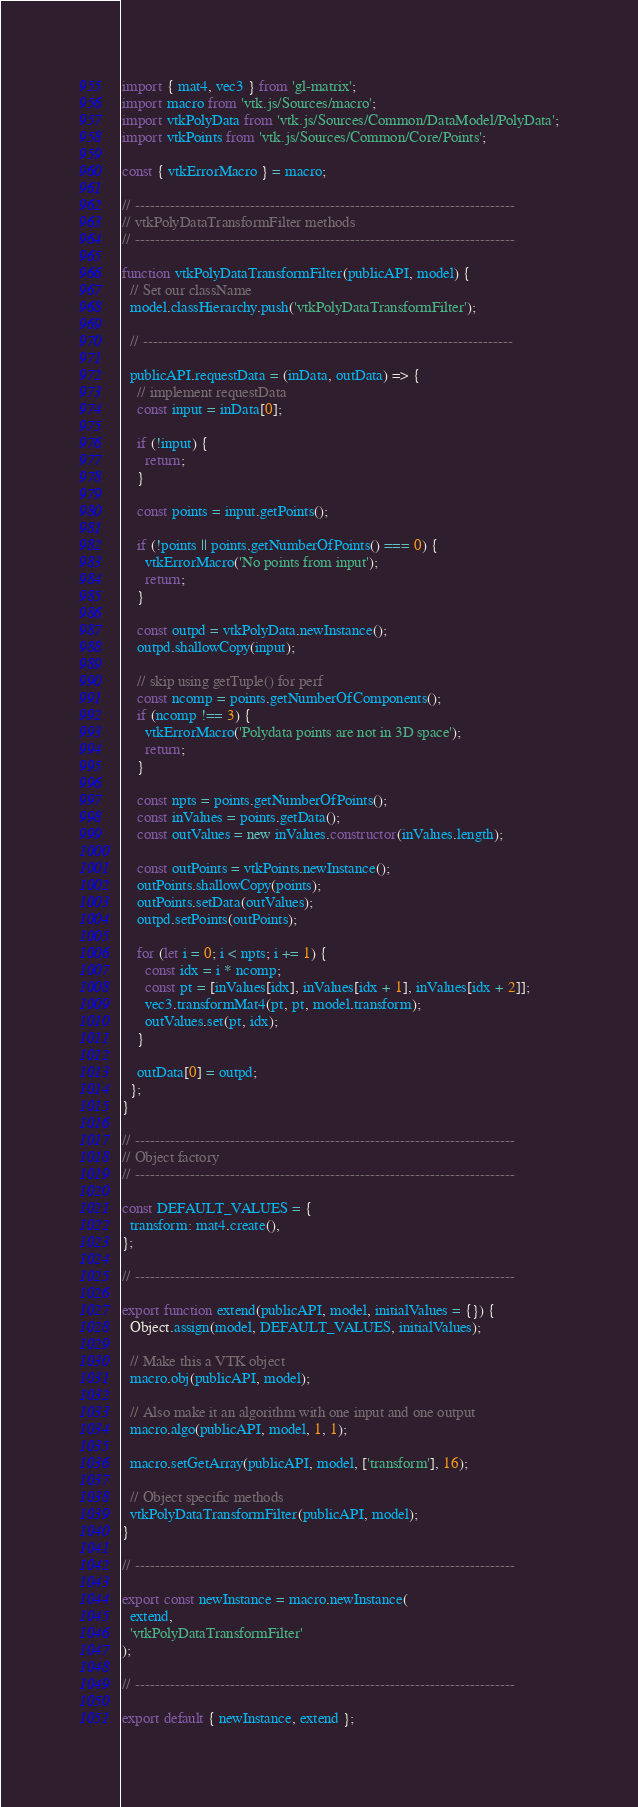<code> <loc_0><loc_0><loc_500><loc_500><_JavaScript_>import { mat4, vec3 } from 'gl-matrix';
import macro from 'vtk.js/Sources/macro';
import vtkPolyData from 'vtk.js/Sources/Common/DataModel/PolyData';
import vtkPoints from 'vtk.js/Sources/Common/Core/Points';

const { vtkErrorMacro } = macro;

// ----------------------------------------------------------------------------
// vtkPolyDataTransformFilter methods
// ----------------------------------------------------------------------------

function vtkPolyDataTransformFilter(publicAPI, model) {
  // Set our className
  model.classHierarchy.push('vtkPolyDataTransformFilter');

  // --------------------------------------------------------------------------

  publicAPI.requestData = (inData, outData) => {
    // implement requestData
    const input = inData[0];

    if (!input) {
      return;
    }

    const points = input.getPoints();

    if (!points || points.getNumberOfPoints() === 0) {
      vtkErrorMacro('No points from input');
      return;
    }

    const outpd = vtkPolyData.newInstance();
    outpd.shallowCopy(input);

    // skip using getTuple() for perf
    const ncomp = points.getNumberOfComponents();
    if (ncomp !== 3) {
      vtkErrorMacro('Polydata points are not in 3D space');
      return;
    }

    const npts = points.getNumberOfPoints();
    const inValues = points.getData();
    const outValues = new inValues.constructor(inValues.length);

    const outPoints = vtkPoints.newInstance();
    outPoints.shallowCopy(points);
    outPoints.setData(outValues);
    outpd.setPoints(outPoints);

    for (let i = 0; i < npts; i += 1) {
      const idx = i * ncomp;
      const pt = [inValues[idx], inValues[idx + 1], inValues[idx + 2]];
      vec3.transformMat4(pt, pt, model.transform);
      outValues.set(pt, idx);
    }

    outData[0] = outpd;
  };
}

// ----------------------------------------------------------------------------
// Object factory
// ----------------------------------------------------------------------------

const DEFAULT_VALUES = {
  transform: mat4.create(),
};

// ----------------------------------------------------------------------------

export function extend(publicAPI, model, initialValues = {}) {
  Object.assign(model, DEFAULT_VALUES, initialValues);

  // Make this a VTK object
  macro.obj(publicAPI, model);

  // Also make it an algorithm with one input and one output
  macro.algo(publicAPI, model, 1, 1);

  macro.setGetArray(publicAPI, model, ['transform'], 16);

  // Object specific methods
  vtkPolyDataTransformFilter(publicAPI, model);
}

// ----------------------------------------------------------------------------

export const newInstance = macro.newInstance(
  extend,
  'vtkPolyDataTransformFilter'
);

// ----------------------------------------------------------------------------

export default { newInstance, extend };
</code> 